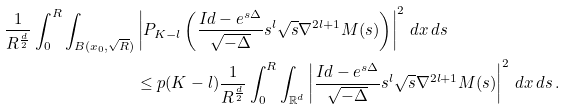<formula> <loc_0><loc_0><loc_500><loc_500>\frac { 1 } { R ^ { \frac { d } { 2 } } } \int _ { 0 } ^ { R } \int _ { B ( x _ { 0 } , \sqrt { R } ) } & \left | P _ { K - l } \left ( \frac { I d - e ^ { s \Delta } } { \sqrt { - \Delta } } s ^ { l } \sqrt { s } \nabla ^ { 2 l + 1 } M ( s ) \right ) \right | ^ { 2 } \, d x \, d s \\ & \leq p ( K - l ) \frac { 1 } { R ^ { \frac { d } { 2 } } } \int _ { 0 } ^ { R } \int _ { { \mathbb { R } } ^ { d } } \left | \frac { I d - e ^ { s \Delta } } { \sqrt { - \Delta } } s ^ { l } \sqrt { s } \nabla ^ { 2 l + 1 } M ( s ) \right | ^ { 2 } \, d x \, d s \, .</formula> 